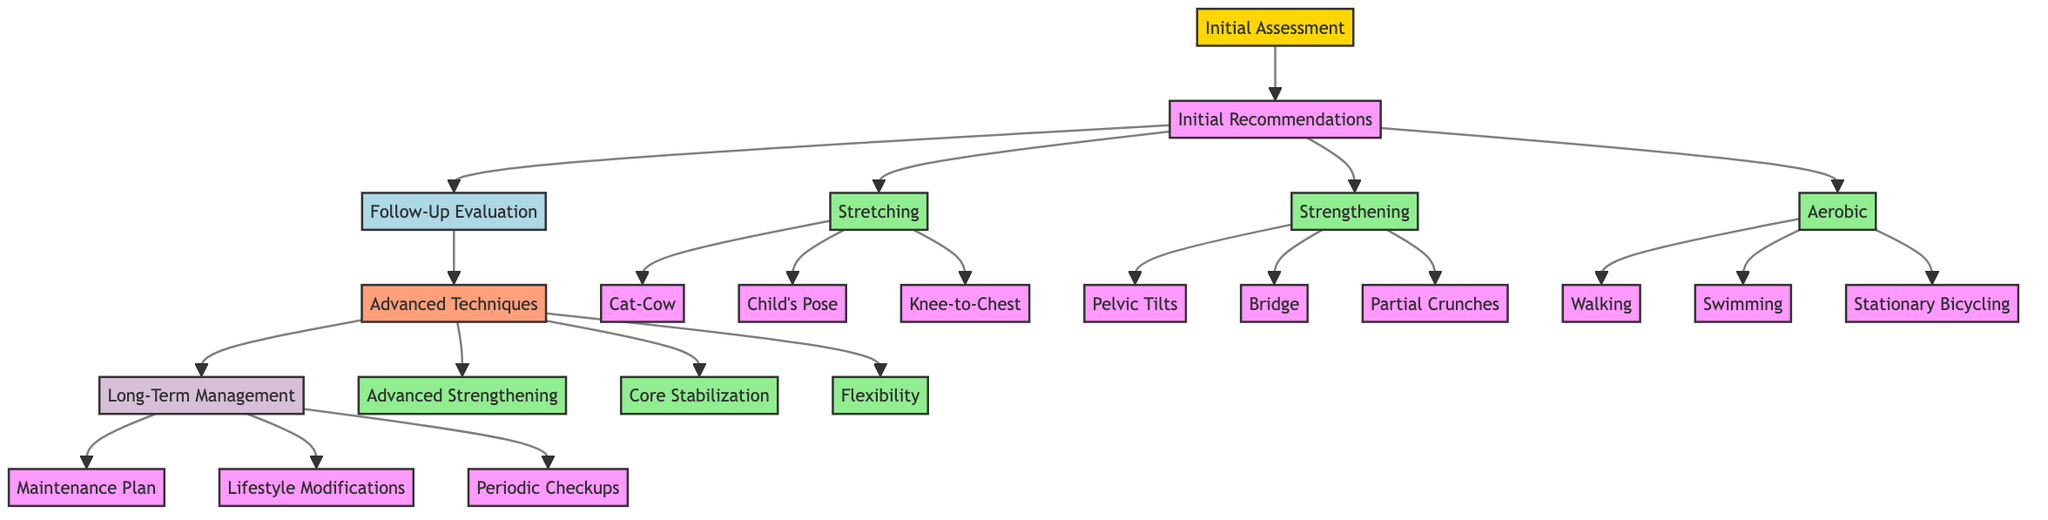What is the first step in the clinical pathway? The diagram shows that the initial step in the clinical pathway is "Initial Assessment".
Answer: Initial Assessment How many types of initial recommendations are there? The diagram indicates three types of initial recommendations: Stretching, Strengthening, and Aerobic exercises.
Answer: Three What follows the Follow-Up Evaluation in the pathway? According to the diagram, "Advanced Techniques" is the phase that comes after the Follow-Up Evaluation.
Answer: Advanced Techniques What exercise is listed under Core Stabilization Techniques? The diagram lists "Bird Dog" as one of the exercises under Core Stabilization Techniques.
Answer: Bird Dog What is part of the Long-Term Management phase? The Long-Term Management phase includes "Maintenance Plan", "Lifestyle Modifications", and "Periodic Checkups".
Answer: Maintenance Plan Which type of exercise involves flexibility enhancements? The diagram specifies that "Flexibility Enhancements" falls under Advanced Techniques, indicating it includes exercises specifically for increasing flexibility.
Answer: Flexibility Enhancements How many different Aerobic exercises are suggested? The diagram indicates there are three suggested Aerobic exercises: Walking, Swimming, and Stationary Bicycling.
Answer: Three What assessment tool is used for pain measurement? The diagram indicates that the Visual Analog Scale (VAS) is utilized to measure pain levels during the Initial Assessment.
Answer: Visual Analog Scale Which exercises are categorized as Initial Recommendations? The Initial Recommendations categorize exercises into Stretching, Strengthening, and Aerobic exercises, with specific examples provided under each category in the diagram.
Answer: Stretching, Strengthening, Aerobic 